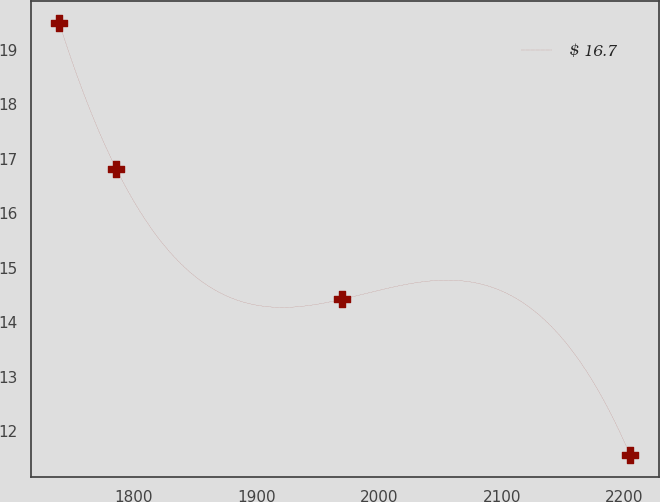<chart> <loc_0><loc_0><loc_500><loc_500><line_chart><ecel><fcel>$ 16.7<nl><fcel>1739.42<fcel>19.49<nl><fcel>1785.95<fcel>16.81<nl><fcel>1969.58<fcel>14.42<nl><fcel>2204.69<fcel>11.56<nl></chart> 